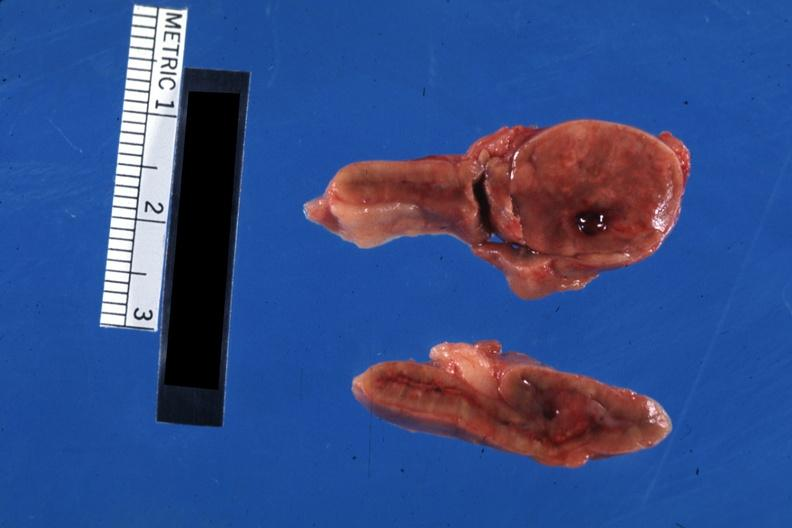does this image show nicely shown single nodule close-up?
Answer the question using a single word or phrase. Yes 